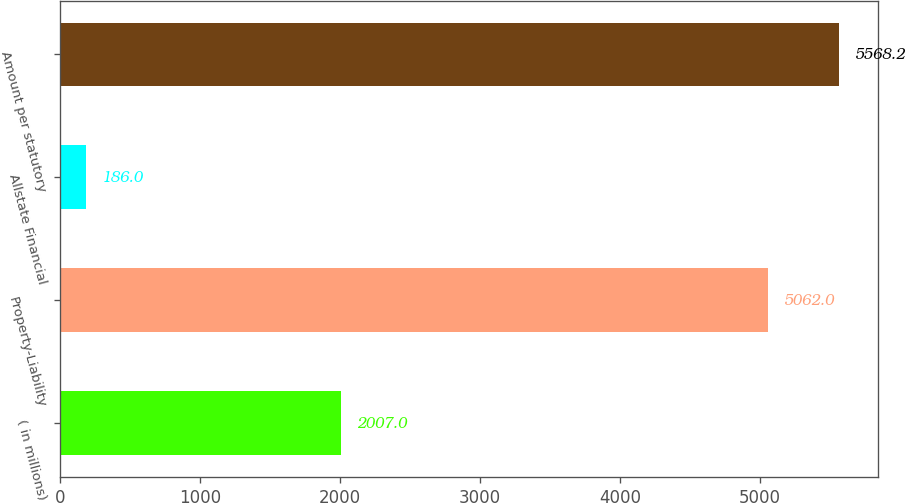Convert chart to OTSL. <chart><loc_0><loc_0><loc_500><loc_500><bar_chart><fcel>( in millions)<fcel>Property-Liability<fcel>Allstate Financial<fcel>Amount per statutory<nl><fcel>2007<fcel>5062<fcel>186<fcel>5568.2<nl></chart> 